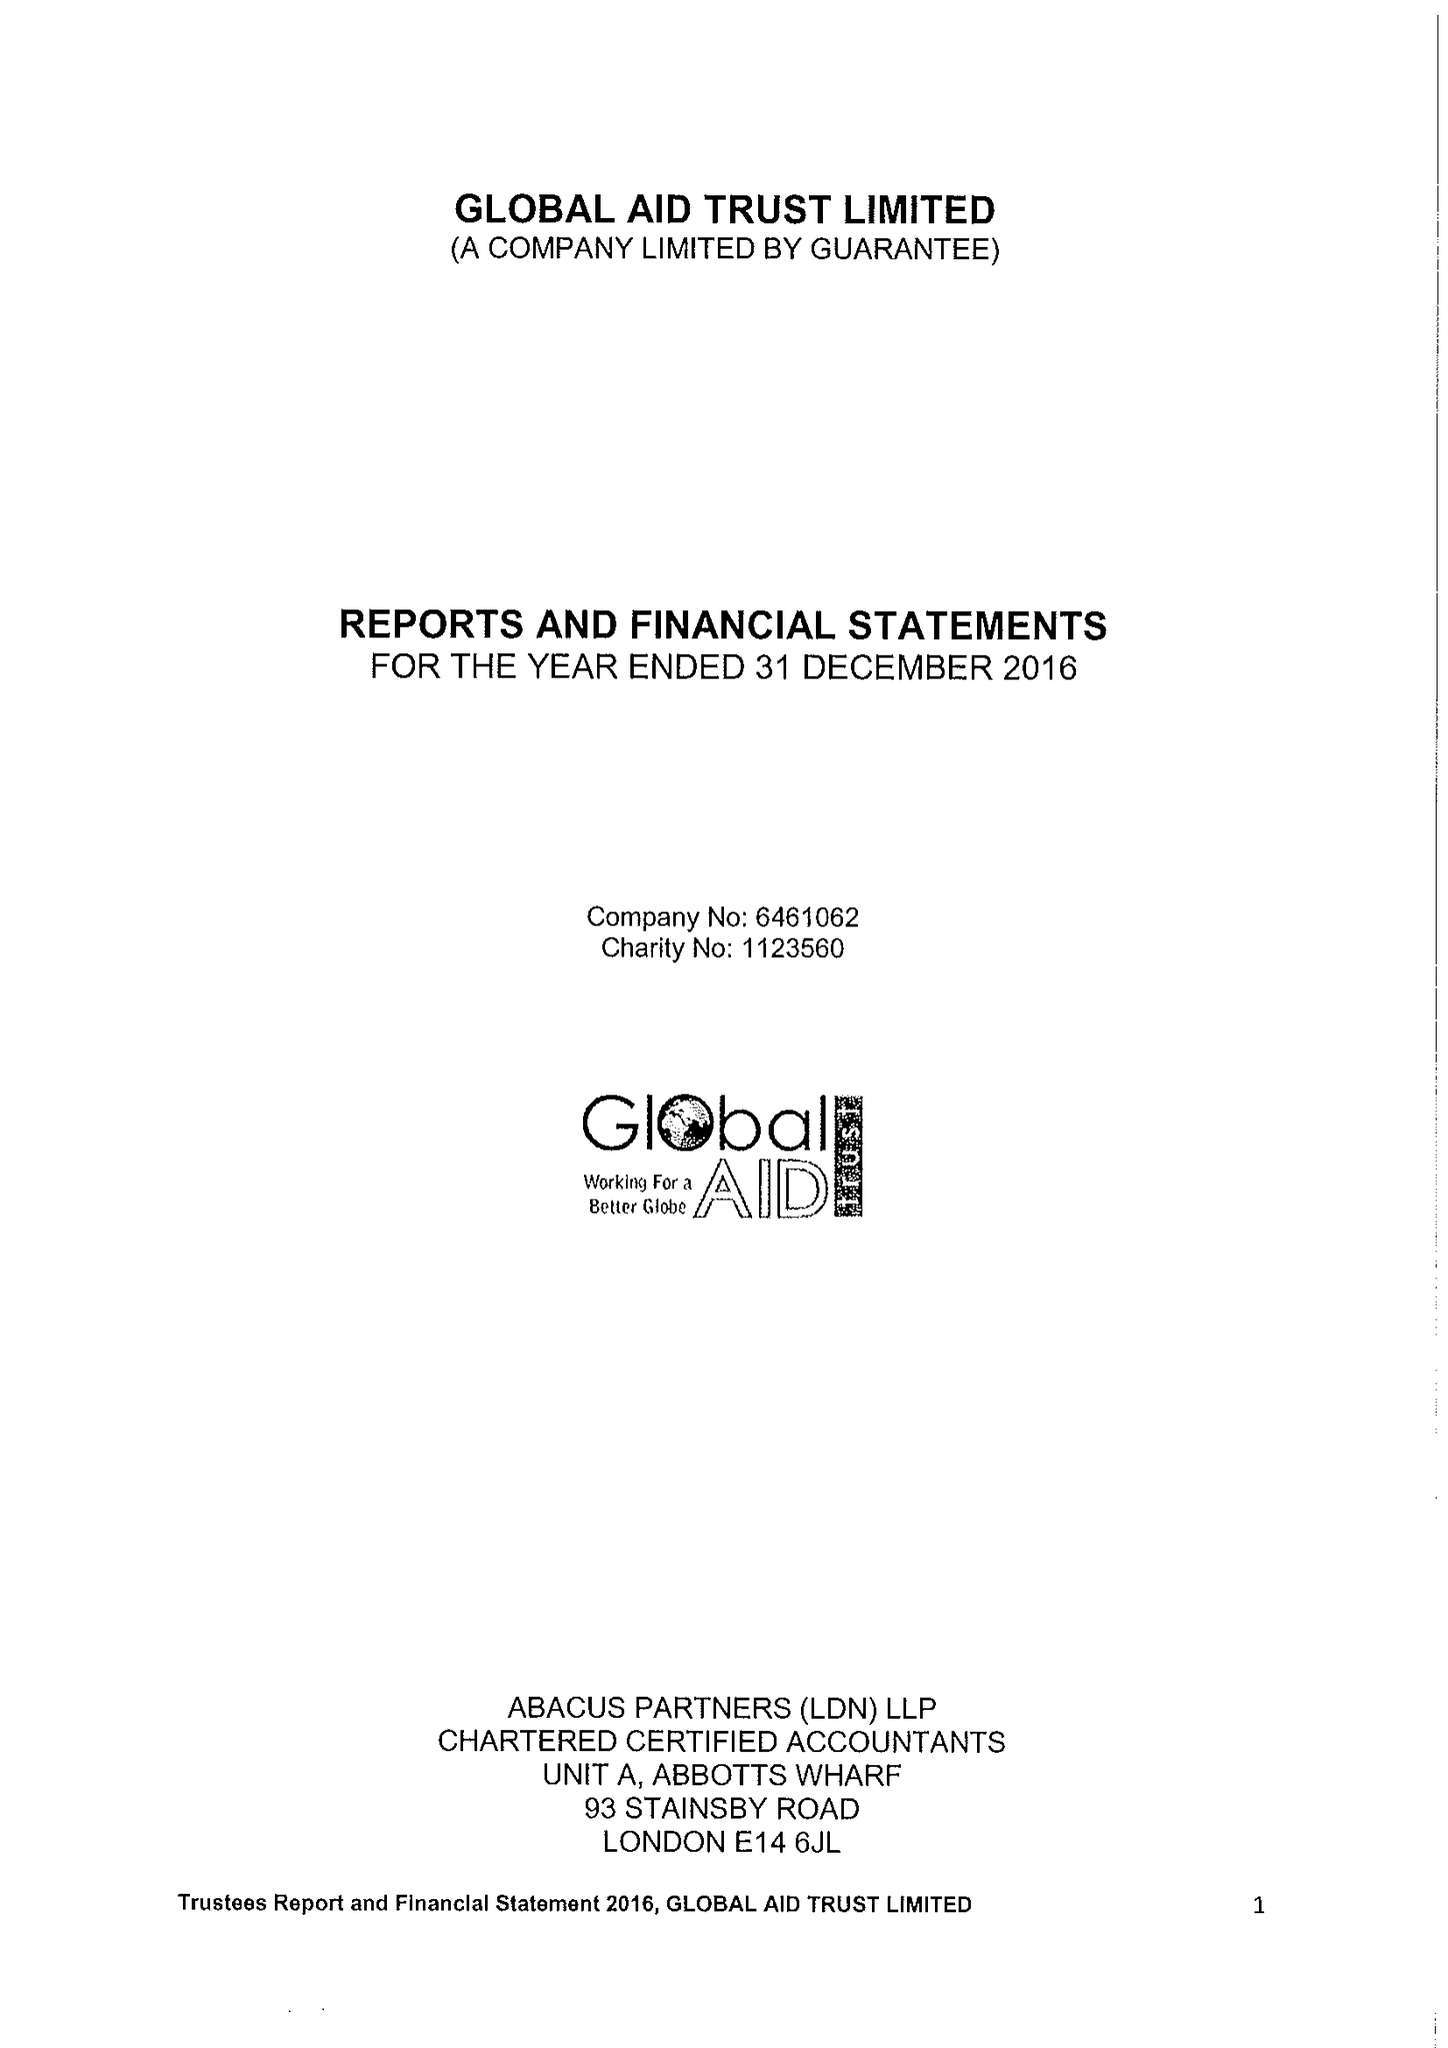What is the value for the charity_name?
Answer the question using a single word or phrase. Global Aid Trust Ltd. 